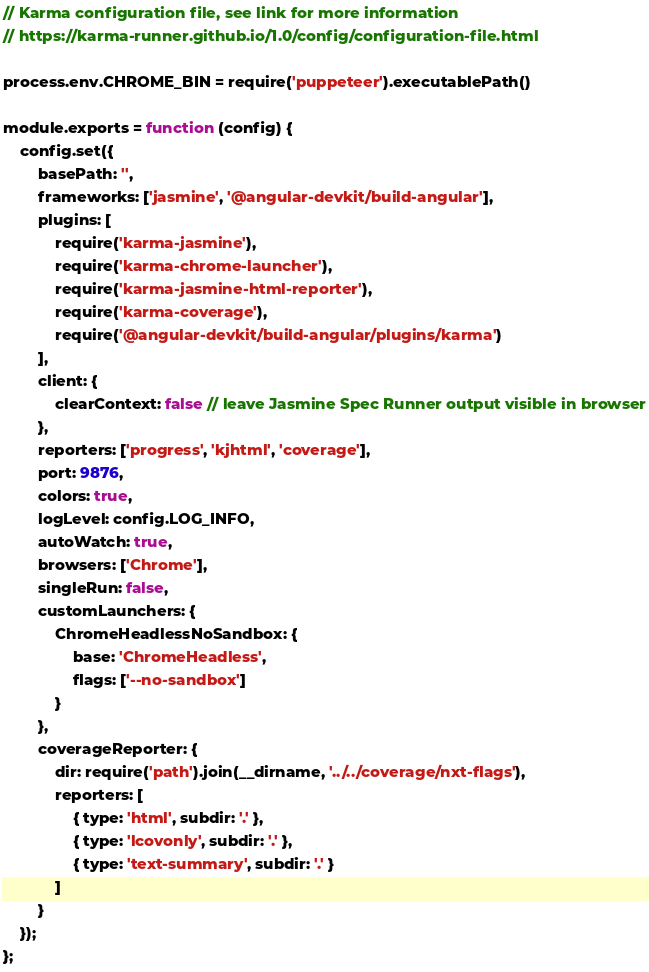Convert code to text. <code><loc_0><loc_0><loc_500><loc_500><_JavaScript_>// Karma configuration file, see link for more information
// https://karma-runner.github.io/1.0/config/configuration-file.html

process.env.CHROME_BIN = require('puppeteer').executablePath()

module.exports = function (config) {
    config.set({
        basePath: '',
        frameworks: ['jasmine', '@angular-devkit/build-angular'],
        plugins: [
            require('karma-jasmine'),
            require('karma-chrome-launcher'),
            require('karma-jasmine-html-reporter'),
            require('karma-coverage'),
            require('@angular-devkit/build-angular/plugins/karma')
        ],
        client: {
            clearContext: false // leave Jasmine Spec Runner output visible in browser
        },
        reporters: ['progress', 'kjhtml', 'coverage'],
        port: 9876,
        colors: true,
        logLevel: config.LOG_INFO,
        autoWatch: true,
        browsers: ['Chrome'],
        singleRun: false,
        customLaunchers: {
            ChromeHeadlessNoSandbox: {
                base: 'ChromeHeadless',
                flags: ['--no-sandbox']
            }
        },
        coverageReporter: {
            dir: require('path').join(__dirname, '../../coverage/nxt-flags'),
            reporters: [
                { type: 'html', subdir: '.' },
                { type: 'lcovonly', subdir: '.' },
                { type: 'text-summary', subdir: '.' }
            ]
        }
    });
};
</code> 